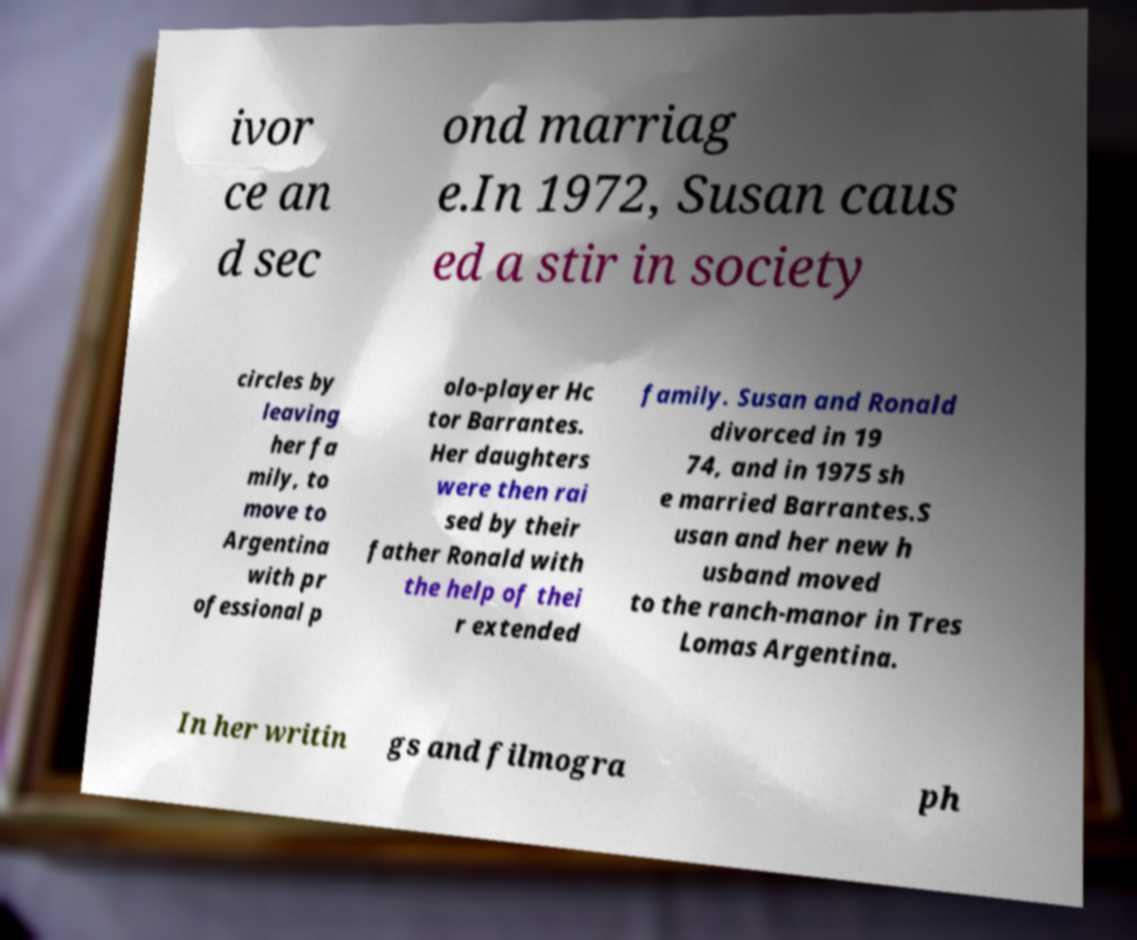Please identify and transcribe the text found in this image. ivor ce an d sec ond marriag e.In 1972, Susan caus ed a stir in society circles by leaving her fa mily, to move to Argentina with pr ofessional p olo-player Hc tor Barrantes. Her daughters were then rai sed by their father Ronald with the help of thei r extended family. Susan and Ronald divorced in 19 74, and in 1975 sh e married Barrantes.S usan and her new h usband moved to the ranch-manor in Tres Lomas Argentina. In her writin gs and filmogra ph 